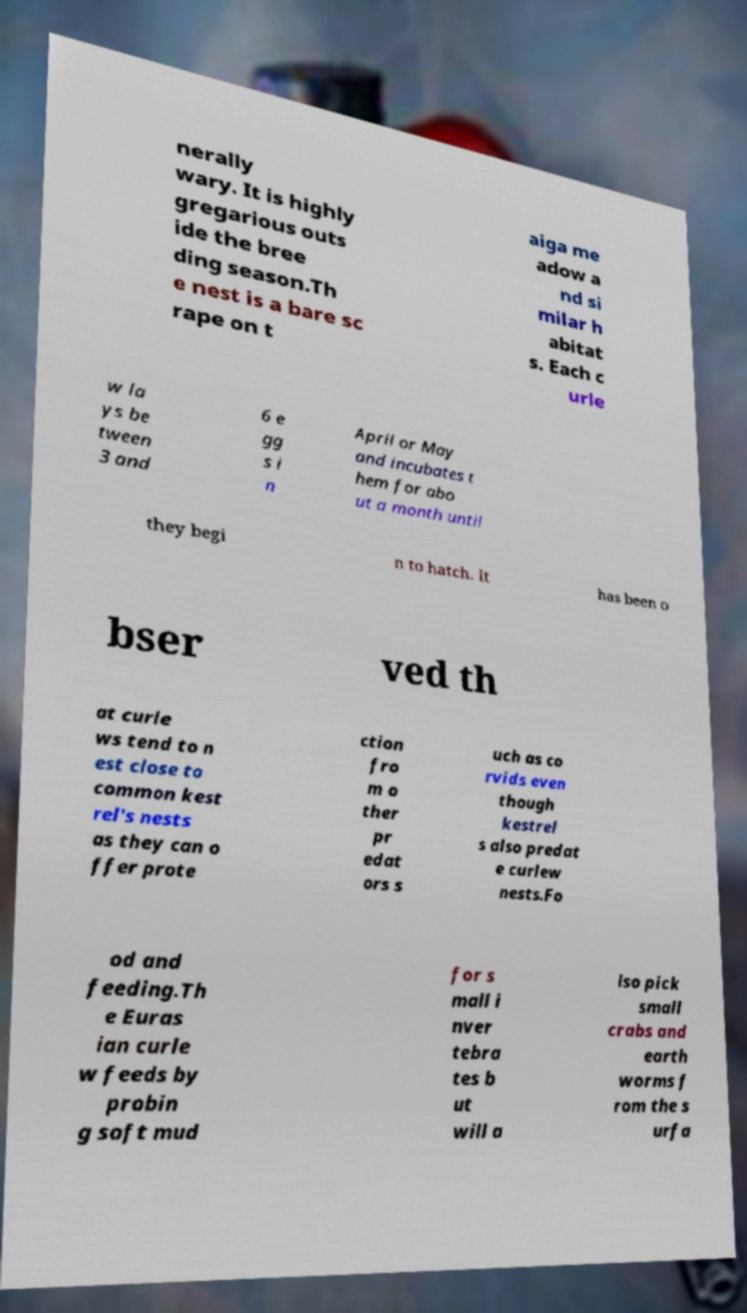There's text embedded in this image that I need extracted. Can you transcribe it verbatim? nerally wary. It is highly gregarious outs ide the bree ding season.Th e nest is a bare sc rape on t aiga me adow a nd si milar h abitat s. Each c urle w la ys be tween 3 and 6 e gg s i n April or May and incubates t hem for abo ut a month until they begi n to hatch. It has been o bser ved th at curle ws tend to n est close to common kest rel's nests as they can o ffer prote ction fro m o ther pr edat ors s uch as co rvids even though kestrel s also predat e curlew nests.Fo od and feeding.Th e Euras ian curle w feeds by probin g soft mud for s mall i nver tebra tes b ut will a lso pick small crabs and earth worms f rom the s urfa 